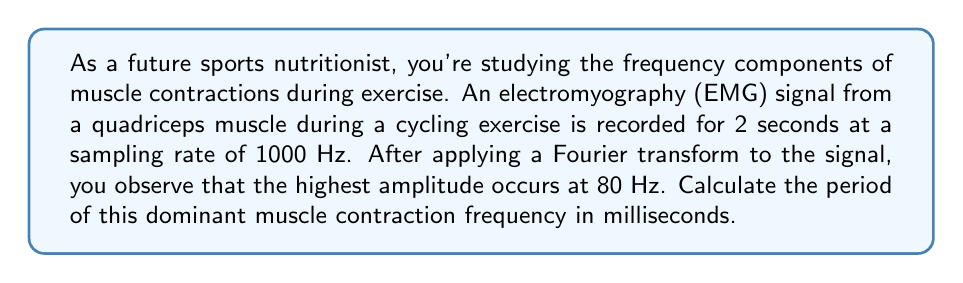Provide a solution to this math problem. To solve this problem, we need to understand the relationship between frequency and period, and how to convert between different units of time. Let's break it down step-by-step:

1) The frequency ($f$) and period ($T$) are inversely related. The formula is:

   $$T = \frac{1}{f}$$

2) We're given the frequency in Hz (cycles per second). The dominant frequency is 80 Hz.

3) Let's plug this into our formula:

   $$T = \frac{1}{80} \text{ seconds}$$

4) To convert this to milliseconds, we multiply by 1000:

   $$T = \frac{1}{80} \cdot 1000 \text{ milliseconds}$$

5) Now we can calculate:

   $$T = \frac{1000}{80} = 12.5 \text{ milliseconds}$$

Thus, the period of the dominant muscle contraction frequency is 12.5 milliseconds.
Answer: 12.5 milliseconds 